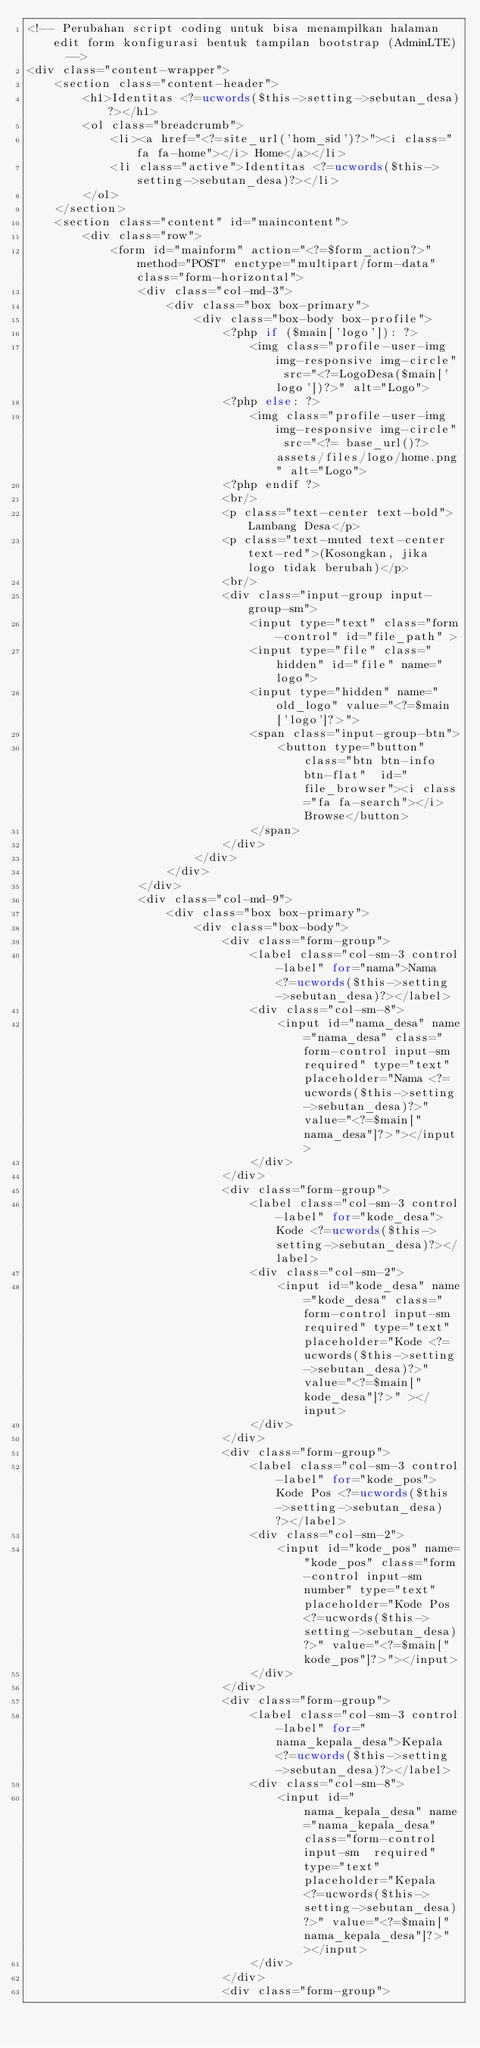Convert code to text. <code><loc_0><loc_0><loc_500><loc_500><_PHP_><!-- Perubahan script coding untuk bisa menampilkan halaman edit form konfigurasi bentuk tampilan bootstrap (AdminLTE)  -->
<div class="content-wrapper">
	<section class="content-header">
		<h1>Identitas <?=ucwords($this->setting->sebutan_desa)?></h1>
		<ol class="breadcrumb">
			<li><a href="<?=site_url('hom_sid')?>"><i class="fa fa-home"></i> Home</a></li>
			<li class="active">Identitas <?=ucwords($this->setting->sebutan_desa)?></li>
		</ol>
	</section>
	<section class="content" id="maincontent">
		<div class="row">
			<form id="mainform" action="<?=$form_action?>" method="POST" enctype="multipart/form-data" class="form-horizontal">
				<div class="col-md-3">
					<div class="box box-primary">
						<div class="box-body box-profile">
							<?php if ($main['logo']): ?>
								<img class="profile-user-img img-responsive img-circle" src="<?=LogoDesa($main['logo'])?>" alt="Logo">
							<?php else: ?>
								<img class="profile-user-img img-responsive img-circle" src="<?= base_url()?>assets/files/logo/home.png" alt="Logo">
							<?php endif ?>
							<br/>
							<p class="text-center text-bold">Lambang Desa</p>
							<p class="text-muted text-center text-red">(Kosongkan, jika logo tidak berubah)</p>
							<br/>
							<div class="input-group input-group-sm">
								<input type="text" class="form-control" id="file_path" >
								<input type="file" class="hidden" id="file" name="logo">
								<input type="hidden" name="old_logo" value="<?=$main['logo']?>">
								<span class="input-group-btn">
									<button type="button" class="btn btn-info btn-flat"  id="file_browser"><i class="fa fa-search"></i> Browse</button>
								</span>
							</div>
						</div>
					</div>
				</div>
				<div class="col-md-9">
					<div class="box box-primary">
						<div class="box-body">
							<div class="form-group">
								<label class="col-sm-3 control-label" for="nama">Nama <?=ucwords($this->setting->sebutan_desa)?></label>
								<div class="col-sm-8">
									<input id="nama_desa" name="nama_desa" class="form-control input-sm required" type="text" placeholder="Nama <?=ucwords($this->setting->sebutan_desa)?>" value="<?=$main["nama_desa"]?>"></input>
								</div>
							</div>
							<div class="form-group">
								<label class="col-sm-3 control-label" for="kode_desa">Kode <?=ucwords($this->setting->sebutan_desa)?></label>
								<div class="col-sm-2">
									<input id="kode_desa" name="kode_desa" class="form-control input-sm required" type="text" placeholder="Kode <?=ucwords($this->setting->sebutan_desa)?>" value="<?=$main["kode_desa"]?>" ></input>
								</div>
							</div>
							<div class="form-group">
								<label class="col-sm-3 control-label" for="kode_pos">Kode Pos <?=ucwords($this->setting->sebutan_desa)?></label>
								<div class="col-sm-2">
									<input id="kode_pos" name="kode_pos" class="form-control input-sm number" type="text" placeholder="Kode Pos <?=ucwords($this->setting->sebutan_desa)?>" value="<?=$main["kode_pos"]?>"></input>
								</div>
							</div>
							<div class="form-group">
								<label class="col-sm-3 control-label" for="nama_kepala_desa">Kepala <?=ucwords($this->setting->sebutan_desa)?></label>
								<div class="col-sm-8">
									<input id="nama_kepala_desa" name="nama_kepala_desa" class="form-control input-sm  required" type="text" placeholder="Kepala <?=ucwords($this->setting->sebutan_desa)?>" value="<?=$main["nama_kepala_desa"]?>"></input>
								</div>
							</div>
							<div class="form-group"></code> 